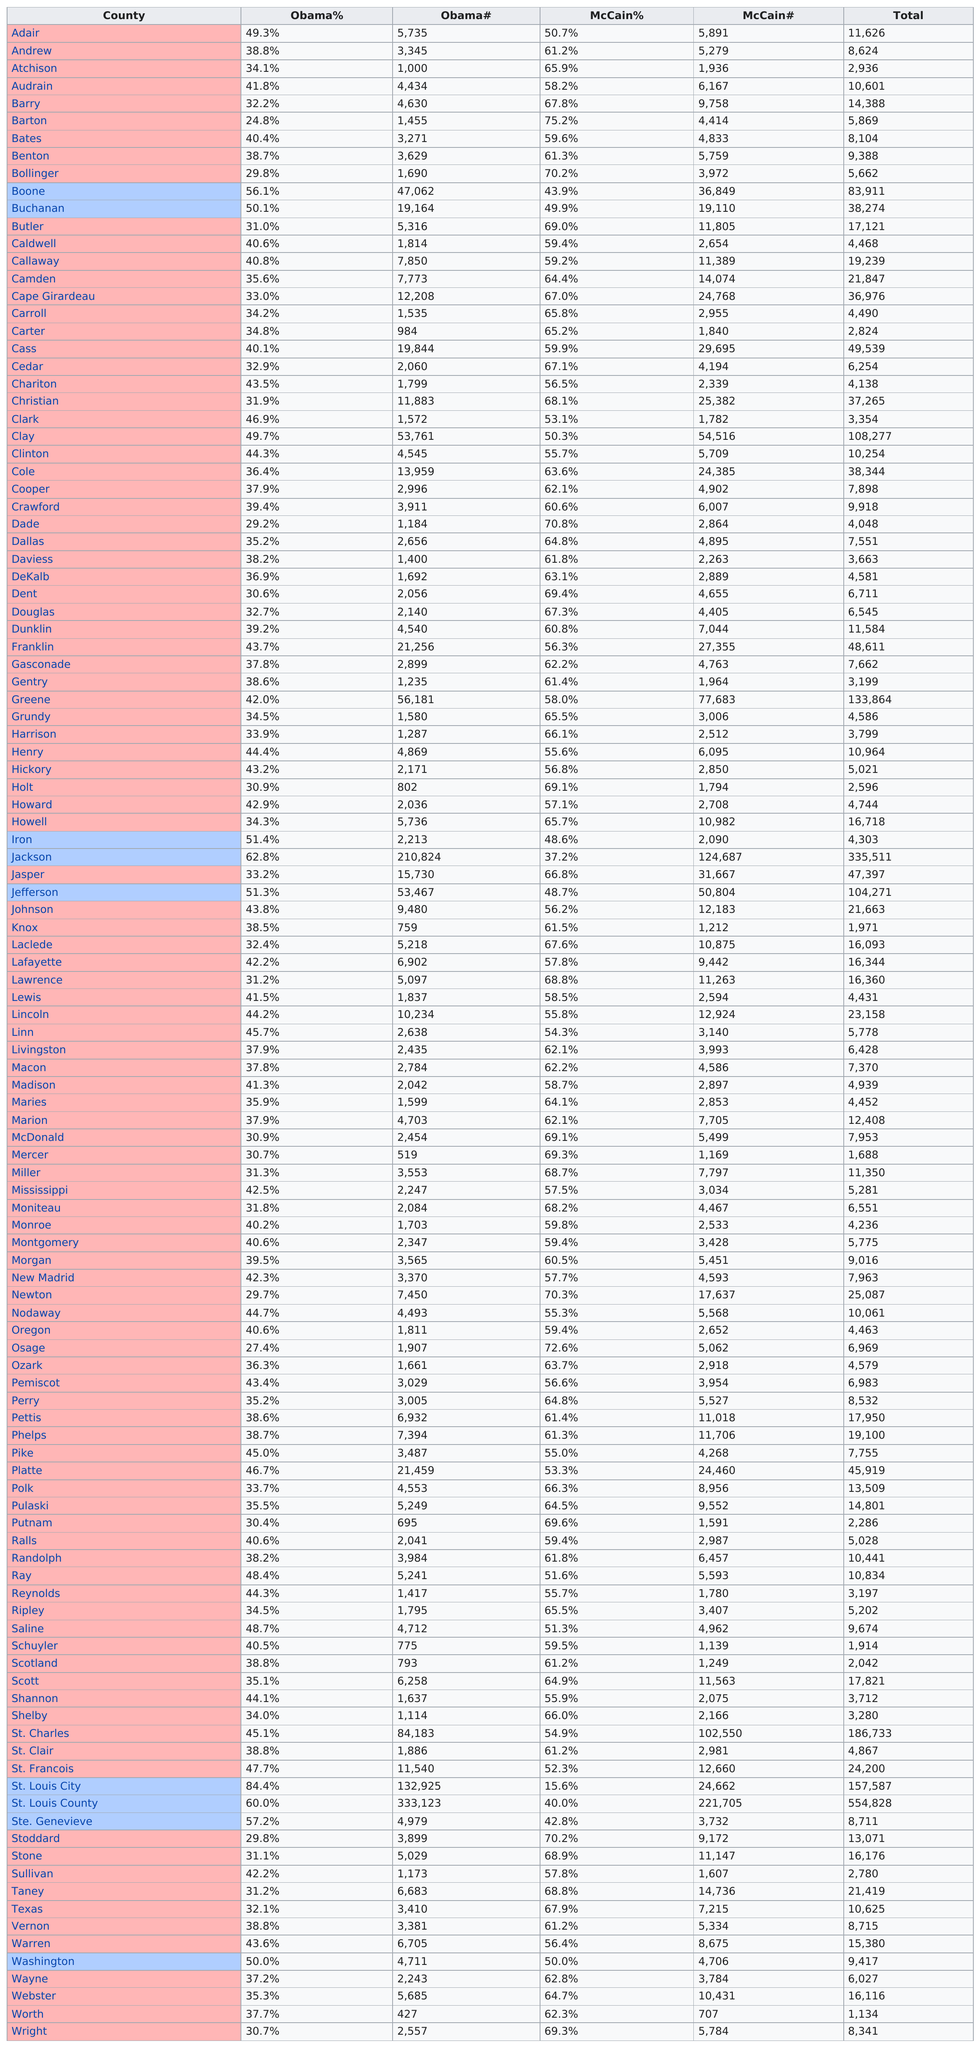Identify some key points in this picture. In Butler County, John McCain received more votes than Barack Obama in the 2008 presidential election. Benton County has the lowest total when compared to Barry County. In Boone County, John McCain had 36,849 voters. Barack Obama won the majority of votes in Adair County during the 2008 presidential election, but John McCain received the largest percentage of votes in the county. Barack Obama won by 123 votes in Iron County. 